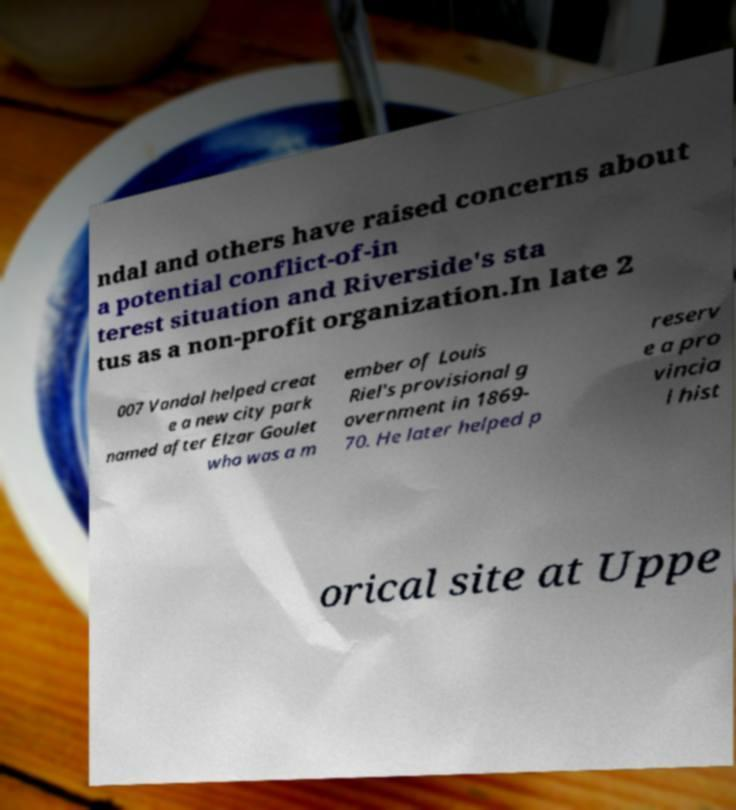Please read and relay the text visible in this image. What does it say? ndal and others have raised concerns about a potential conflict-of-in terest situation and Riverside's sta tus as a non-profit organization.In late 2 007 Vandal helped creat e a new city park named after Elzar Goulet who was a m ember of Louis Riel's provisional g overnment in 1869- 70. He later helped p reserv e a pro vincia l hist orical site at Uppe 